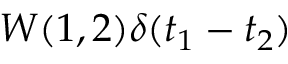<formula> <loc_0><loc_0><loc_500><loc_500>W ( 1 , 2 ) \delta ( t _ { 1 } - t _ { 2 } )</formula> 